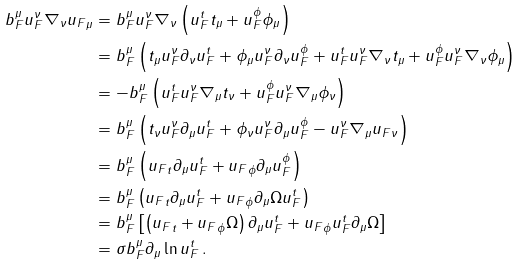<formula> <loc_0><loc_0><loc_500><loc_500>b _ { F } ^ { \mu } u _ { F } ^ { \nu } \nabla _ { \nu } { u _ { F } } _ { \mu } & = b _ { F } ^ { \mu } u _ { F } ^ { \nu } \nabla _ { \nu } \left ( u _ { F } ^ { t } t _ { \mu } + u _ { F } ^ { \phi } \phi _ { \mu } \right ) \\ & = b _ { F } ^ { \mu } \left ( t _ { \mu } u _ { F } ^ { \nu } \partial _ { \nu } u _ { F } ^ { t } + \phi _ { \mu } u _ { F } ^ { \nu } \partial _ { \nu } u _ { F } ^ { \phi } + u _ { F } ^ { t } u _ { F } ^ { \nu } \nabla _ { \nu } t _ { \mu } + u _ { F } ^ { \phi } u _ { F } ^ { \nu } \nabla _ { \nu } \phi _ { \mu } \right ) \\ & = - b _ { F } ^ { \mu } \left ( u _ { F } ^ { t } u _ { F } ^ { \nu } \nabla _ { \mu } t _ { \nu } + u _ { F } ^ { \phi } u _ { F } ^ { \nu } \nabla _ { \mu } \phi _ { \nu } \right ) \\ & = b _ { F } ^ { \mu } \left ( t _ { \nu } u _ { F } ^ { \nu } \partial _ { \mu } u _ { F } ^ { t } + \phi _ { \nu } u _ { F } ^ { \nu } \partial _ { \mu } u _ { F } ^ { \phi } - u _ { F } ^ { \nu } \nabla _ { \mu } { u _ { F } } _ { \nu } \right ) \\ & = b _ { F } ^ { \mu } \left ( { u _ { F } } _ { t } \partial _ { \mu } u _ { F } ^ { t } + { u _ { F } } _ { \phi } \partial _ { \mu } u _ { F } ^ { \phi } \right ) \\ & = b _ { F } ^ { \mu } \left ( { u _ { F } } _ { t } \partial _ { \mu } u _ { F } ^ { t } + { u _ { F } } _ { \phi } \partial _ { \mu } \Omega u _ { F } ^ { t } \right ) \\ & = b _ { F } ^ { \mu } \left [ \left ( { u _ { F } } _ { t } + { u _ { F } } _ { \phi } \Omega \right ) \partial _ { \mu } u _ { F } ^ { t } + { u _ { F } } _ { \phi } u _ { F } ^ { t } \partial _ { \mu } \Omega \right ] \\ & = \sigma b _ { F } ^ { \mu } \partial _ { \mu } \ln u _ { F } ^ { t } \, .</formula> 